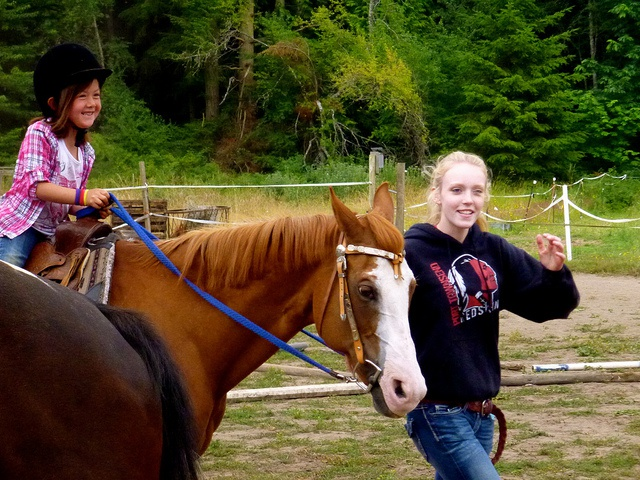Describe the objects in this image and their specific colors. I can see horse in darkgreen, maroon, brown, black, and lightgray tones, people in darkgreen, black, navy, lightgray, and tan tones, horse in darkgreen, black, gray, and maroon tones, and people in darkgreen, black, maroon, violet, and lavender tones in this image. 